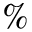Convert formula to latex. <formula><loc_0><loc_0><loc_500><loc_500>\%</formula> 